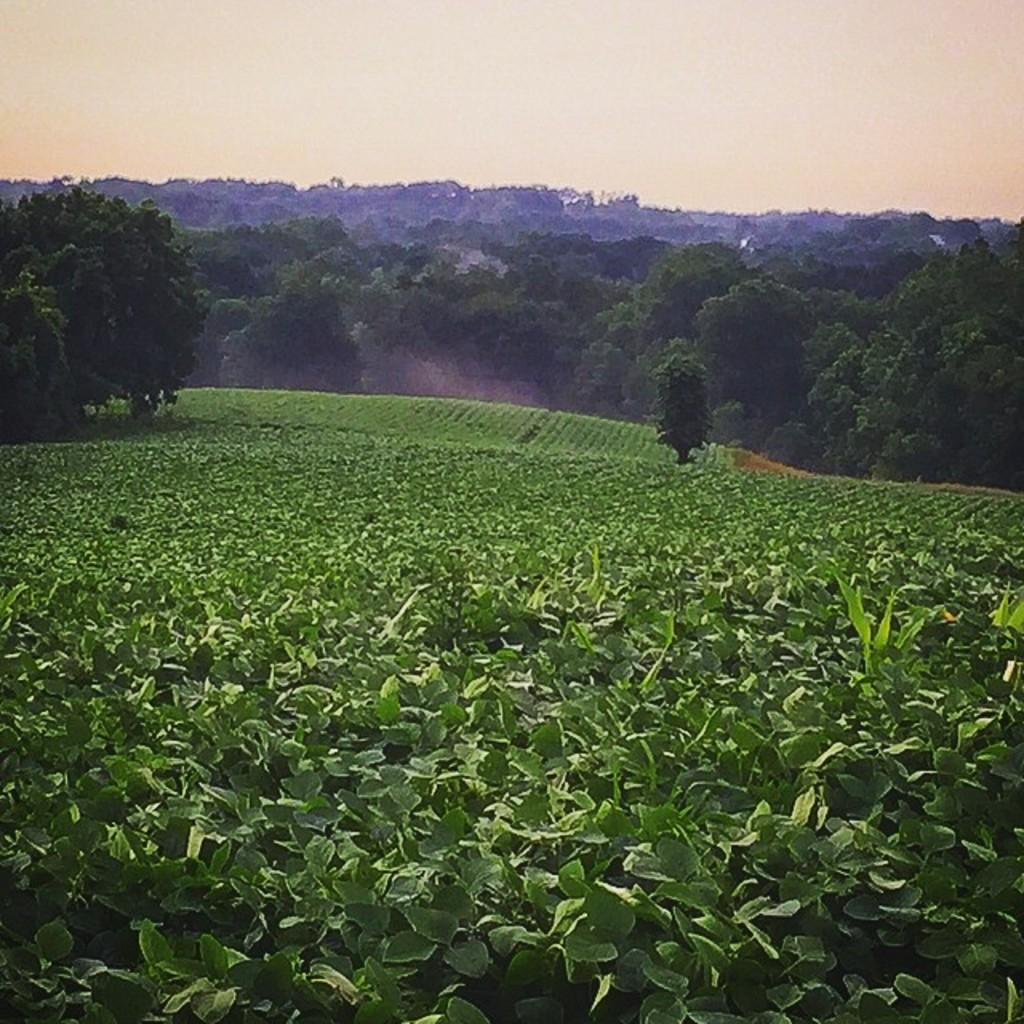What type of vegetation can be seen in the image? There are plants and trees in the image. What can be seen in the background of the image? The sky is visible in the background of the image. What type of wool is being used to make the sack in the image? There is no sack or wool present in the image; it features plants, trees, and the sky. 